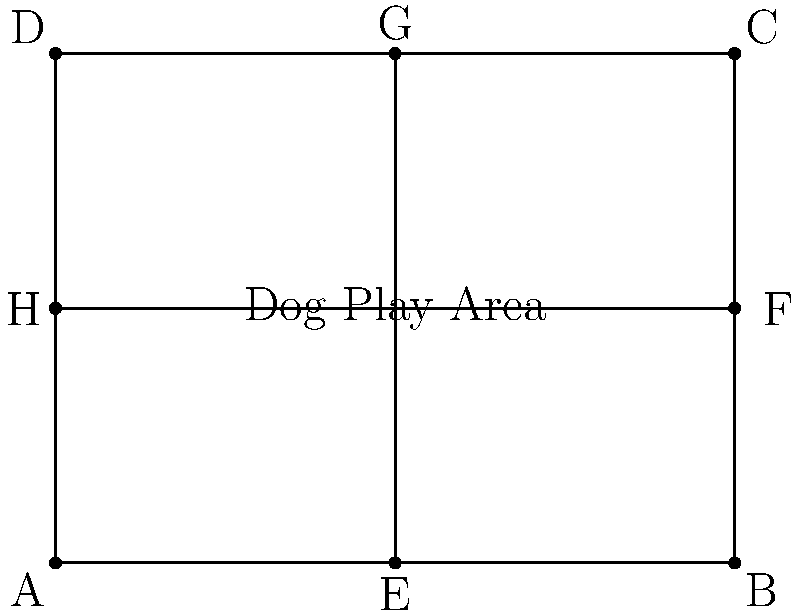A local dog park has a rectangular layout as shown in the diagram. The park is divided into four equal sections by two perpendicular paths. If a rotation of 180° around the center point is applied, followed by a reflection across the vertical path, which point will coincide with point B? Let's approach this step-by-step:

1) First, let's consider the 180° rotation around the center point:
   - This rotation will move each point to its opposite corner.
   - A goes to C, B goes to D, C goes to A, and D goes to B.

2) After this rotation, we need to reflect the result across the vertical path:
   - The vertical path is the line EG in the diagram.
   - Reflection across a vertical line swaps points on either side of the line.

3) Let's track the movement of point D:
   - After the 180° rotation, D is at B's original position.
   - When we then reflect across EG, B stays in the same place because it's on the line of reflection.

4) Therefore, after both transformations, the point that was originally at D ends up at B.

5) To verify:
   - Point A rotates to C, then reflects to A.
   - Point B rotates to D, then reflects to B.
   - Point C rotates to A, then reflects to C.
   - Point D rotates to B, then stays at B.

Thus, point D is the one that coincides with point B after these transformations.
Answer: D 